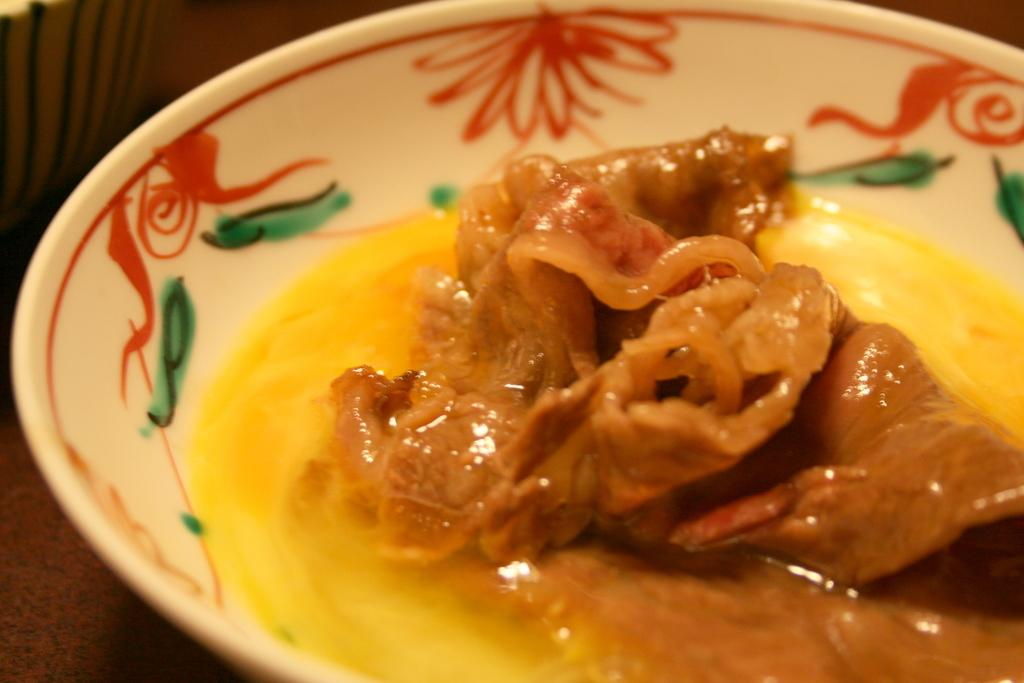What is the main subject of the image? The main subject of the image is a food item on a plate. Can you describe the object that the plate is on? Unfortunately, the facts provided do not give any information about the object that the plate is on. What type of disease is affecting the food item on the plate in the image? There is no indication of any disease affecting the food item in the image. 